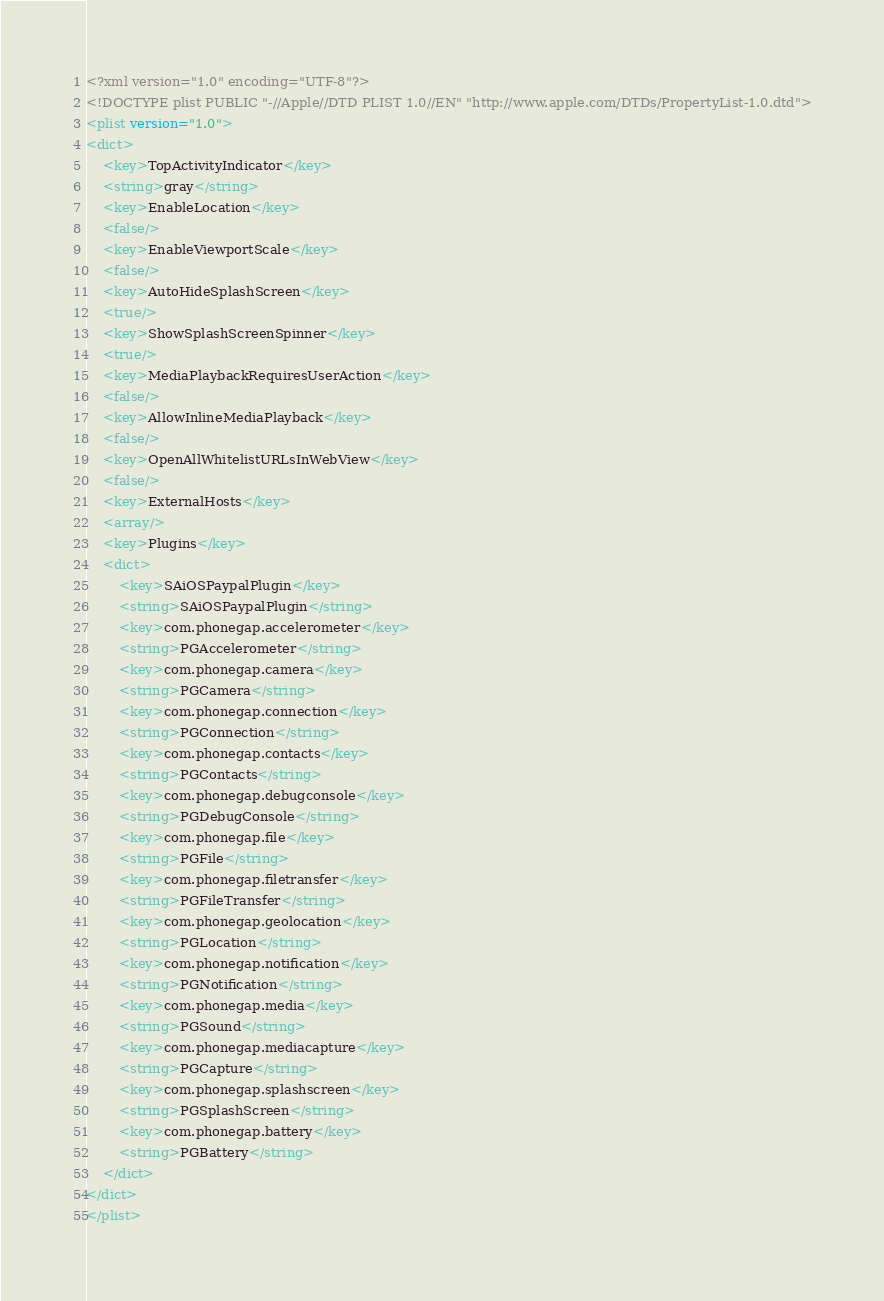<code> <loc_0><loc_0><loc_500><loc_500><_XML_><?xml version="1.0" encoding="UTF-8"?>
<!DOCTYPE plist PUBLIC "-//Apple//DTD PLIST 1.0//EN" "http://www.apple.com/DTDs/PropertyList-1.0.dtd">
<plist version="1.0">
<dict>
	<key>TopActivityIndicator</key>
	<string>gray</string>
	<key>EnableLocation</key>
	<false/>
	<key>EnableViewportScale</key>
	<false/>
	<key>AutoHideSplashScreen</key>
	<true/>
	<key>ShowSplashScreenSpinner</key>
	<true/>
	<key>MediaPlaybackRequiresUserAction</key>
	<false/>
	<key>AllowInlineMediaPlayback</key>
	<false/>
	<key>OpenAllWhitelistURLsInWebView</key>
	<false/>
	<key>ExternalHosts</key>
	<array/>
	<key>Plugins</key>
	<dict>
		<key>SAiOSPaypalPlugin</key>
		<string>SAiOSPaypalPlugin</string>
		<key>com.phonegap.accelerometer</key>
		<string>PGAccelerometer</string>
		<key>com.phonegap.camera</key>
		<string>PGCamera</string>
		<key>com.phonegap.connection</key>
		<string>PGConnection</string>
		<key>com.phonegap.contacts</key>
		<string>PGContacts</string>
		<key>com.phonegap.debugconsole</key>
		<string>PGDebugConsole</string>
		<key>com.phonegap.file</key>
		<string>PGFile</string>
		<key>com.phonegap.filetransfer</key>
		<string>PGFileTransfer</string>
		<key>com.phonegap.geolocation</key>
		<string>PGLocation</string>
		<key>com.phonegap.notification</key>
		<string>PGNotification</string>
		<key>com.phonegap.media</key>
		<string>PGSound</string>
		<key>com.phonegap.mediacapture</key>
		<string>PGCapture</string>
		<key>com.phonegap.splashscreen</key>
		<string>PGSplashScreen</string>
		<key>com.phonegap.battery</key>
		<string>PGBattery</string>
	</dict>
</dict>
</plist>
</code> 